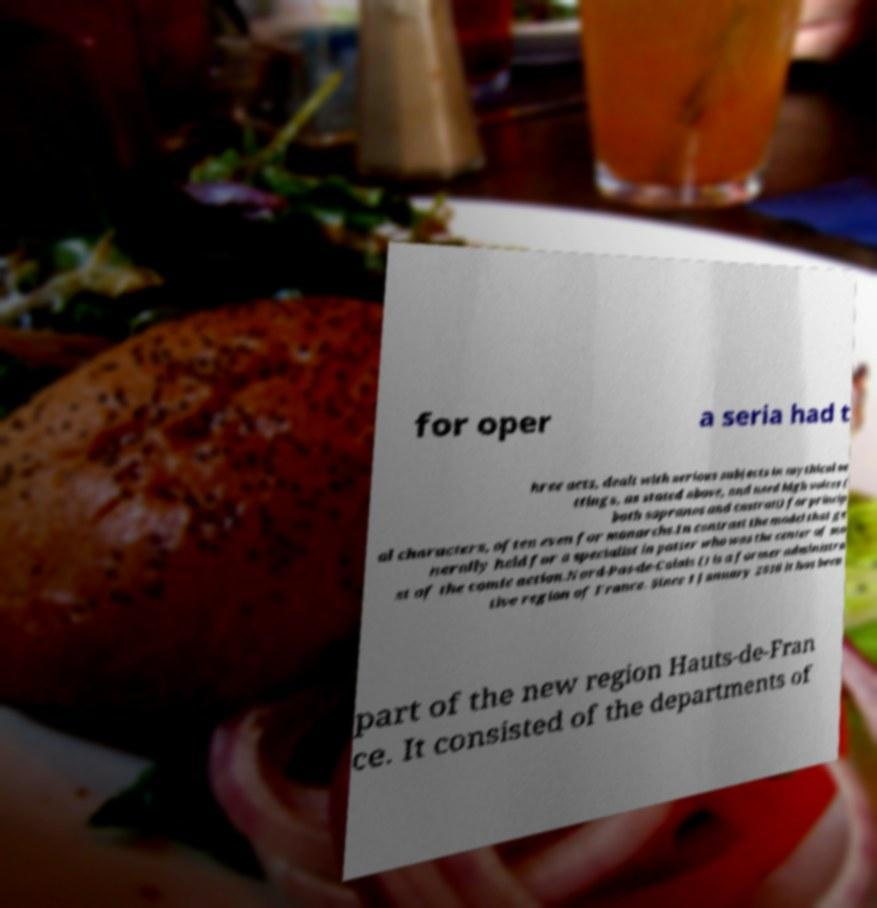Please identify and transcribe the text found in this image. for oper a seria had t hree acts, dealt with serious subjects in mythical se ttings, as stated above, and used high voices ( both sopranos and castrati) for princip al characters, often even for monarchs.In contrast the model that ge nerally held for a specialist in patter who was the center of mo st of the comic action.Nord-Pas-de-Calais () is a former administra tive region of France. Since 1 January 2016 it has been part of the new region Hauts-de-Fran ce. It consisted of the departments of 